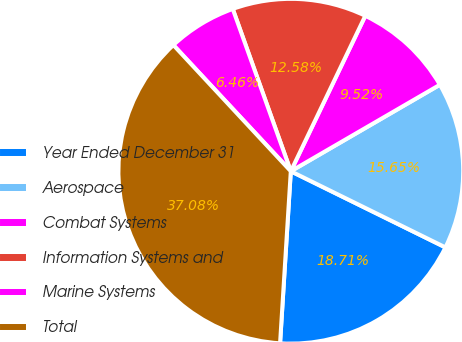<chart> <loc_0><loc_0><loc_500><loc_500><pie_chart><fcel>Year Ended December 31<fcel>Aerospace<fcel>Combat Systems<fcel>Information Systems and<fcel>Marine Systems<fcel>Total<nl><fcel>18.71%<fcel>15.65%<fcel>9.52%<fcel>12.58%<fcel>6.46%<fcel>37.08%<nl></chart> 